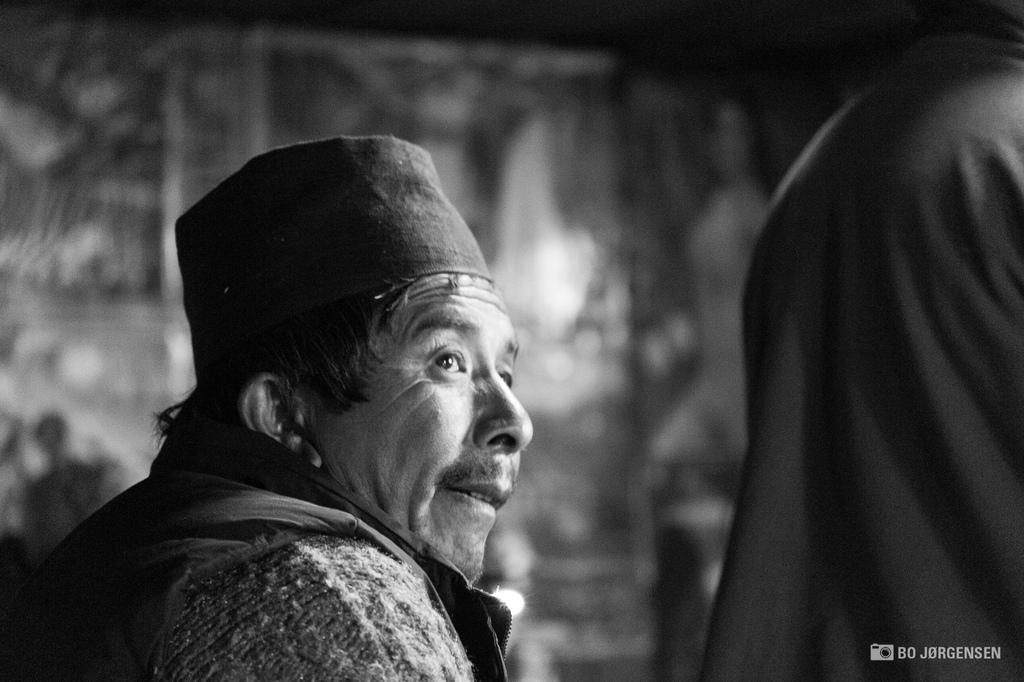What is the main subject in the foreground of the image? There is an old person in the image, and they are in the foreground. What can be observed about the old person's clothing? The old person is wearing a hat. What type of underwear is the old person wearing in the image? There is no information about the old person's underwear in the image. What type of food is the old person cooking in the image? There is no indication that the old person is cooking or preparing any food in the image. 